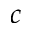<formula> <loc_0><loc_0><loc_500><loc_500>c</formula> 